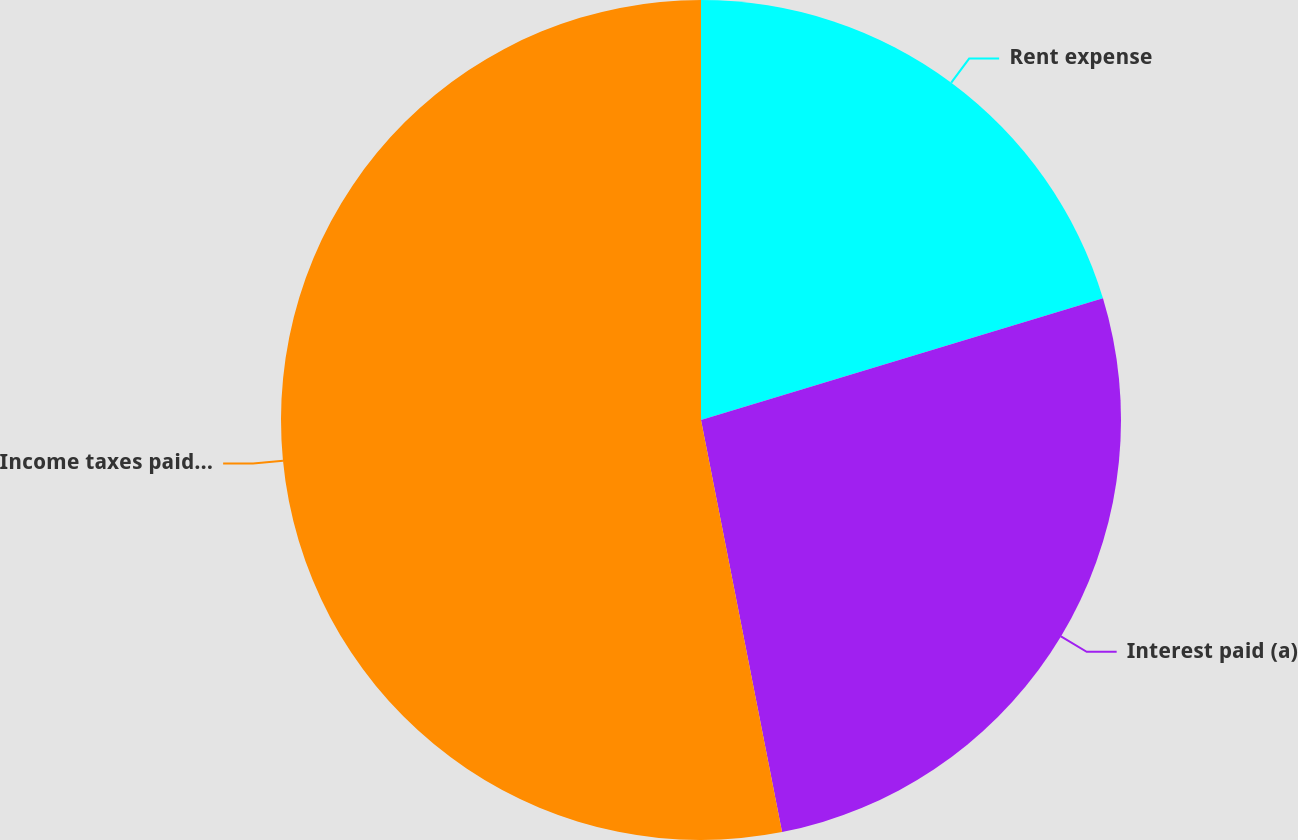<chart> <loc_0><loc_0><loc_500><loc_500><pie_chart><fcel>Rent expense<fcel>Interest paid (a)<fcel>Income taxes paid net of<nl><fcel>20.32%<fcel>26.59%<fcel>53.09%<nl></chart> 